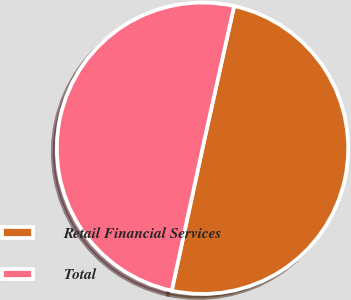Convert chart to OTSL. <chart><loc_0><loc_0><loc_500><loc_500><pie_chart><fcel>Retail Financial Services<fcel>Total<nl><fcel>49.91%<fcel>50.09%<nl></chart> 